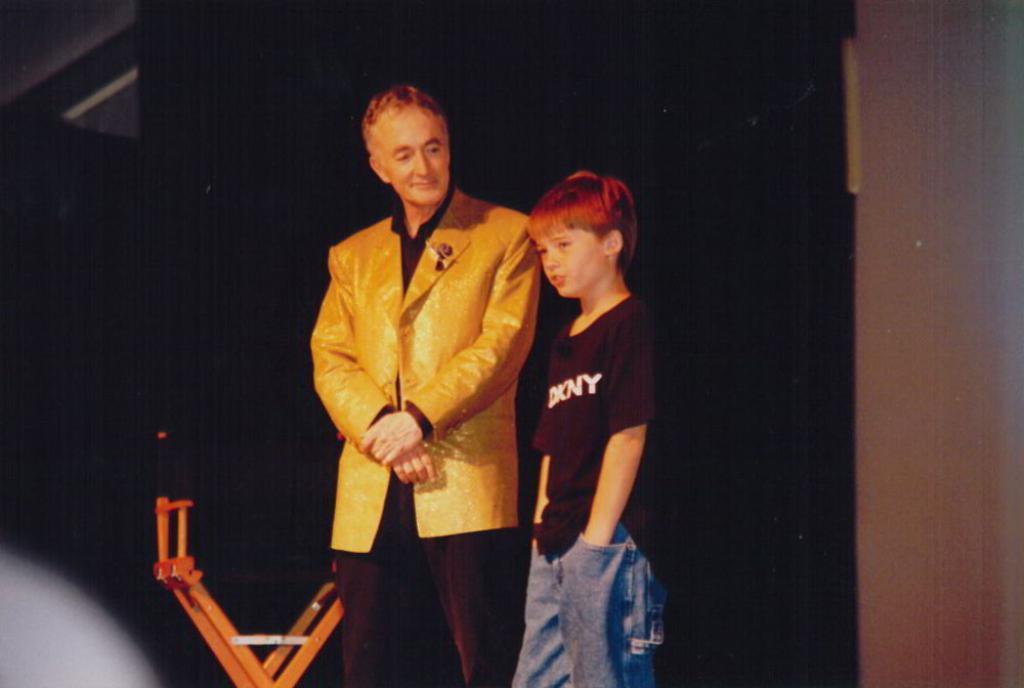Could you give a brief overview of what you see in this image? In this picture we can see two people and in the background we can see some objects. 